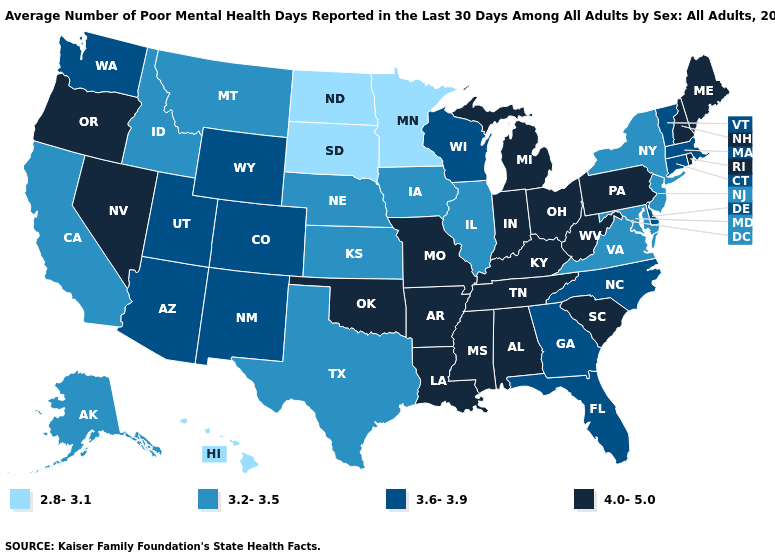Name the states that have a value in the range 2.8-3.1?
Answer briefly. Hawaii, Minnesota, North Dakota, South Dakota. Does Georgia have the same value as Wyoming?
Concise answer only. Yes. Does the map have missing data?
Concise answer only. No. What is the lowest value in the MidWest?
Short answer required. 2.8-3.1. What is the value of New Mexico?
Answer briefly. 3.6-3.9. Does South Dakota have the lowest value in the USA?
Short answer required. Yes. What is the value of Kentucky?
Short answer required. 4.0-5.0. Does Georgia have a lower value than Wisconsin?
Keep it brief. No. Does Washington have the lowest value in the West?
Answer briefly. No. Among the states that border Massachusetts , which have the highest value?
Be succinct. New Hampshire, Rhode Island. Does Nevada have the highest value in the West?
Give a very brief answer. Yes. Does Connecticut have the highest value in the Northeast?
Be succinct. No. What is the lowest value in the Northeast?
Answer briefly. 3.2-3.5. What is the value of Colorado?
Keep it brief. 3.6-3.9. 